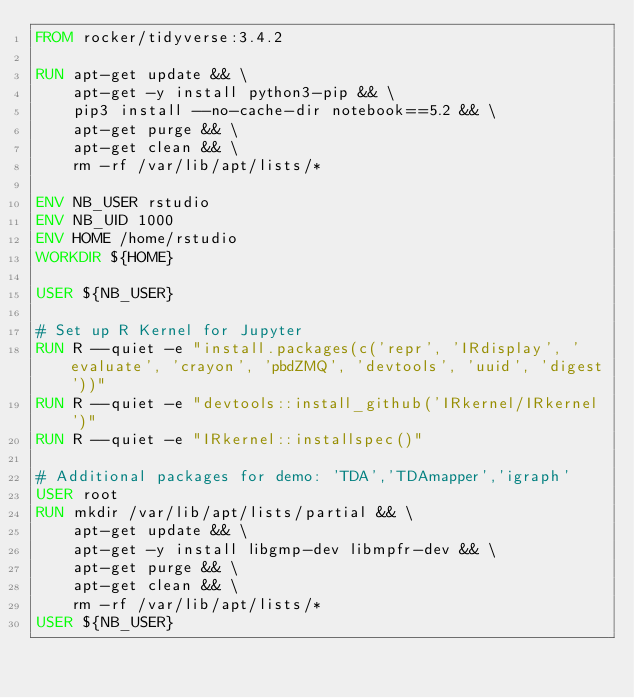<code> <loc_0><loc_0><loc_500><loc_500><_Dockerfile_>FROM rocker/tidyverse:3.4.2

RUN apt-get update && \
    apt-get -y install python3-pip && \
    pip3 install --no-cache-dir notebook==5.2 && \
    apt-get purge && \
    apt-get clean && \
    rm -rf /var/lib/apt/lists/*

ENV NB_USER rstudio
ENV NB_UID 1000
ENV HOME /home/rstudio
WORKDIR ${HOME}

USER ${NB_USER}

# Set up R Kernel for Jupyter
RUN R --quiet -e "install.packages(c('repr', 'IRdisplay', 'evaluate', 'crayon', 'pbdZMQ', 'devtools', 'uuid', 'digest'))"
RUN R --quiet -e "devtools::install_github('IRkernel/IRkernel')"
RUN R --quiet -e "IRkernel::installspec()"

# Additional packages for demo: 'TDA','TDAmapper','igraph'
USER root
RUN mkdir /var/lib/apt/lists/partial && \
    apt-get update && \
    apt-get -y install libgmp-dev libmpfr-dev && \
    apt-get purge && \
    apt-get clean && \
    rm -rf /var/lib/apt/lists/*
USER ${NB_USER}
</code> 